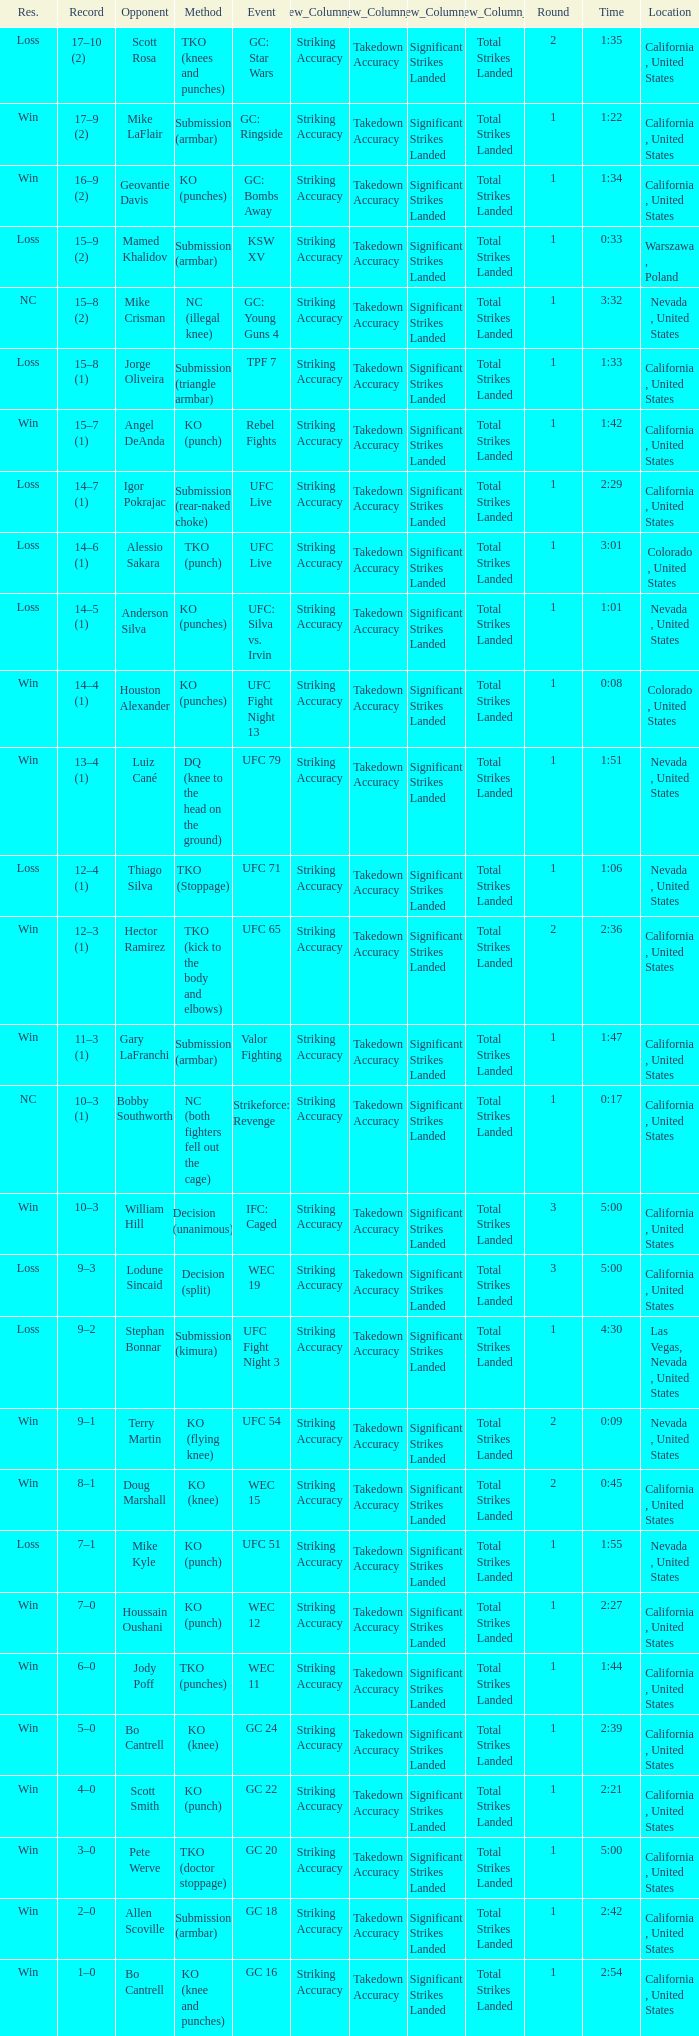What is the method where there is a loss with time 5:00? Decision (split). 